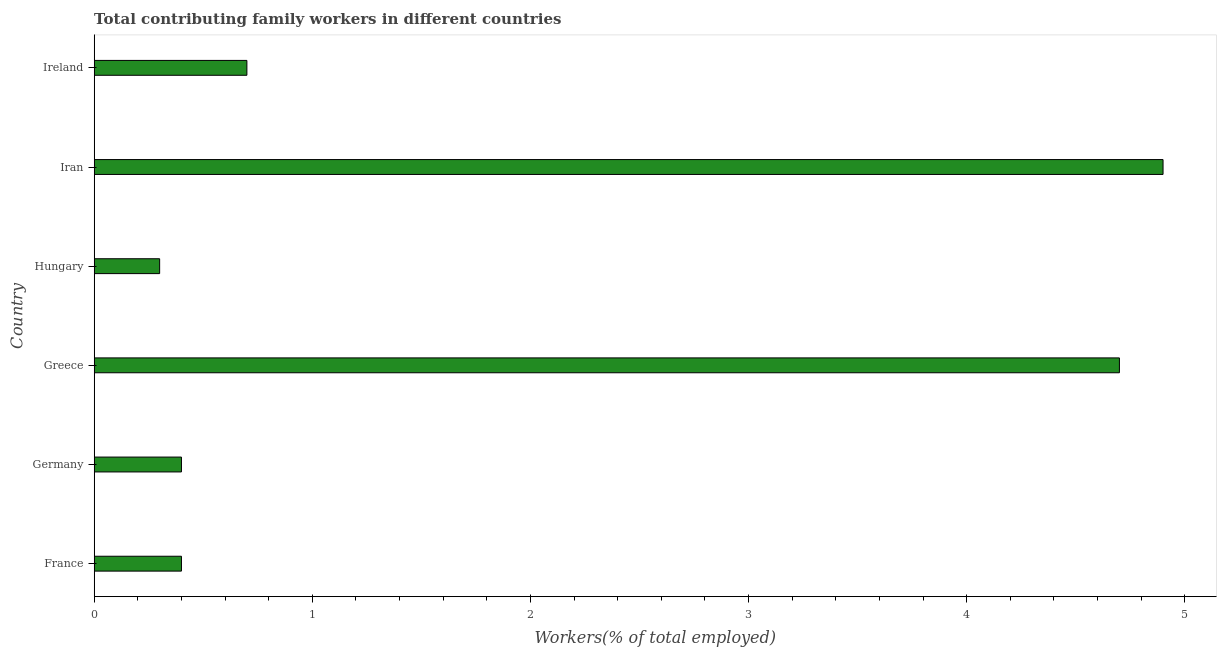Does the graph contain any zero values?
Offer a terse response. No. Does the graph contain grids?
Make the answer very short. No. What is the title of the graph?
Offer a terse response. Total contributing family workers in different countries. What is the label or title of the X-axis?
Ensure brevity in your answer.  Workers(% of total employed). What is the contributing family workers in Ireland?
Provide a short and direct response. 0.7. Across all countries, what is the maximum contributing family workers?
Ensure brevity in your answer.  4.9. Across all countries, what is the minimum contributing family workers?
Offer a very short reply. 0.3. In which country was the contributing family workers maximum?
Give a very brief answer. Iran. In which country was the contributing family workers minimum?
Provide a succinct answer. Hungary. What is the sum of the contributing family workers?
Provide a short and direct response. 11.4. What is the difference between the contributing family workers in Greece and Hungary?
Offer a terse response. 4.4. What is the average contributing family workers per country?
Ensure brevity in your answer.  1.9. What is the median contributing family workers?
Offer a very short reply. 0.55. What is the ratio of the contributing family workers in Germany to that in Greece?
Ensure brevity in your answer.  0.09. Is the contributing family workers in Germany less than that in Ireland?
Give a very brief answer. Yes. Is the difference between the contributing family workers in Hungary and Ireland greater than the difference between any two countries?
Give a very brief answer. No. What is the difference between the highest and the lowest contributing family workers?
Make the answer very short. 4.6. In how many countries, is the contributing family workers greater than the average contributing family workers taken over all countries?
Ensure brevity in your answer.  2. How many bars are there?
Offer a terse response. 6. Are all the bars in the graph horizontal?
Make the answer very short. Yes. How many countries are there in the graph?
Offer a terse response. 6. What is the difference between two consecutive major ticks on the X-axis?
Ensure brevity in your answer.  1. Are the values on the major ticks of X-axis written in scientific E-notation?
Give a very brief answer. No. What is the Workers(% of total employed) of France?
Provide a succinct answer. 0.4. What is the Workers(% of total employed) in Germany?
Your answer should be compact. 0.4. What is the Workers(% of total employed) of Greece?
Provide a succinct answer. 4.7. What is the Workers(% of total employed) of Hungary?
Provide a succinct answer. 0.3. What is the Workers(% of total employed) in Iran?
Your answer should be very brief. 4.9. What is the Workers(% of total employed) of Ireland?
Give a very brief answer. 0.7. What is the difference between the Workers(% of total employed) in France and Germany?
Keep it short and to the point. 0. What is the difference between the Workers(% of total employed) in Germany and Hungary?
Offer a terse response. 0.1. What is the difference between the Workers(% of total employed) in Germany and Iran?
Offer a very short reply. -4.5. What is the difference between the Workers(% of total employed) in Greece and Iran?
Offer a very short reply. -0.2. What is the difference between the Workers(% of total employed) in Greece and Ireland?
Give a very brief answer. 4. What is the difference between the Workers(% of total employed) in Iran and Ireland?
Your answer should be very brief. 4.2. What is the ratio of the Workers(% of total employed) in France to that in Germany?
Ensure brevity in your answer.  1. What is the ratio of the Workers(% of total employed) in France to that in Greece?
Provide a succinct answer. 0.09. What is the ratio of the Workers(% of total employed) in France to that in Hungary?
Offer a very short reply. 1.33. What is the ratio of the Workers(% of total employed) in France to that in Iran?
Your answer should be compact. 0.08. What is the ratio of the Workers(% of total employed) in France to that in Ireland?
Your answer should be compact. 0.57. What is the ratio of the Workers(% of total employed) in Germany to that in Greece?
Make the answer very short. 0.09. What is the ratio of the Workers(% of total employed) in Germany to that in Hungary?
Offer a very short reply. 1.33. What is the ratio of the Workers(% of total employed) in Germany to that in Iran?
Keep it short and to the point. 0.08. What is the ratio of the Workers(% of total employed) in Germany to that in Ireland?
Your answer should be compact. 0.57. What is the ratio of the Workers(% of total employed) in Greece to that in Hungary?
Provide a succinct answer. 15.67. What is the ratio of the Workers(% of total employed) in Greece to that in Ireland?
Your answer should be very brief. 6.71. What is the ratio of the Workers(% of total employed) in Hungary to that in Iran?
Provide a short and direct response. 0.06. What is the ratio of the Workers(% of total employed) in Hungary to that in Ireland?
Ensure brevity in your answer.  0.43. 